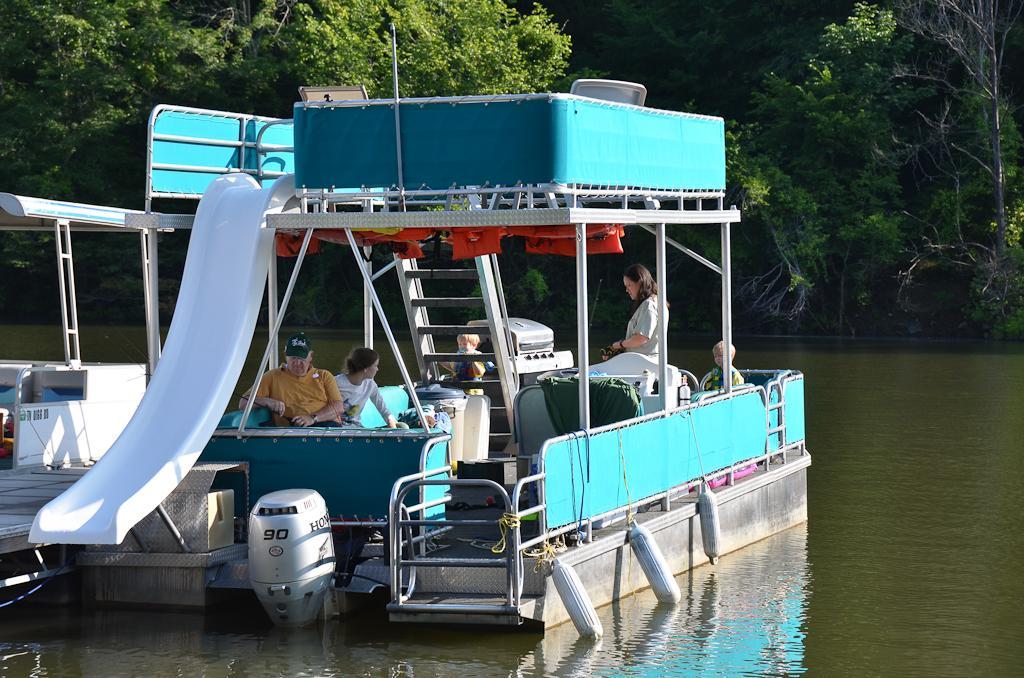Could you give a brief overview of what you see in this image? In this image there is a boat in the water. In the boat there are four persons sitting in it. At the bottom there is a motor in the water. In the background there are trees. 